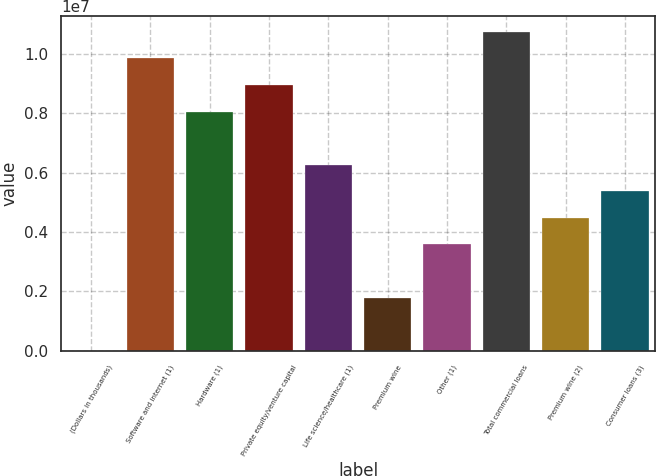<chart> <loc_0><loc_0><loc_500><loc_500><bar_chart><fcel>(Dollars in thousands)<fcel>Software and internet (1)<fcel>Hardware (1)<fcel>Private equity/venture capital<fcel>Life science/healthcare (1)<fcel>Premium wine<fcel>Other (1)<fcel>Total commercial loans<fcel>Premium wine (2)<fcel>Consumer loans (3)<nl><fcel>2012<fcel>9.84143e+06<fcel>8.05244e+06<fcel>8.94693e+06<fcel>6.26346e+06<fcel>1.791e+06<fcel>3.57998e+06<fcel>1.07359e+07<fcel>4.47447e+06<fcel>5.36896e+06<nl></chart> 